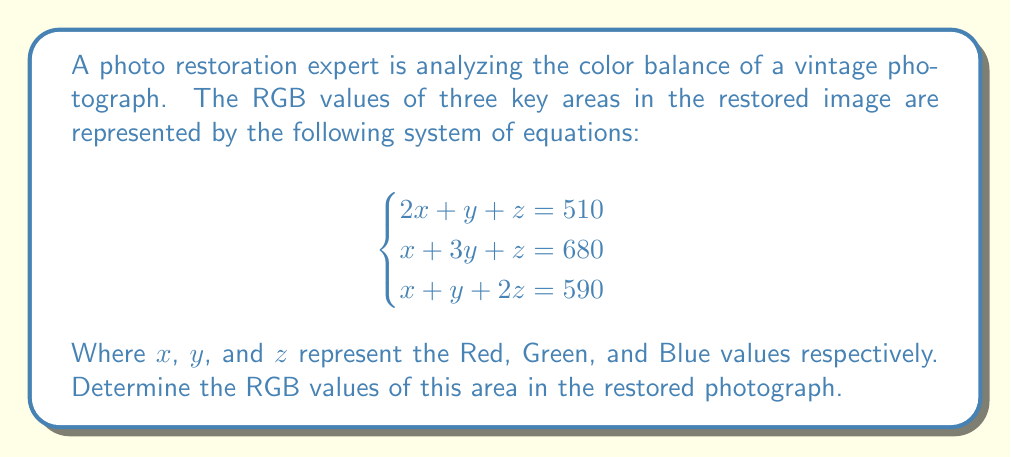Show me your answer to this math problem. To solve this system of equations, we'll use the elimination method:

1) Multiply the first equation by -1 and add it to the second equation:
   $$-2x - y - z = -510$$
   $$x + 3y + z = 680$$
   $$-x + 2y = 170$$ (Equation A)

2) Multiply the first equation by -1 and add it to the third equation:
   $$-2x - y - z = -510$$
   $$x + y + 2z = 590$$
   $$-x + z = 80$$ (Equation B)

3) Multiply Equation A by 2 and add it to Equation B:
   $$-2x + 4y = 340$$
   $$-x + z = 80$$
   $$-3x + 4y + z = 420$$ (Equation C)

4) Multiply the original first equation by 3 and subtract Equation C:
   $$6x + 3y + 3z = 1530$$
   $$-3x + 4y + z = 420$$
   $$9x - y + 2z = 1110$$

5) Multiply this by 1/9 to simplify:
   $$x - \frac{1}{9}y + \frac{2}{9}z = 123.33$$ (Equation D)

6) Subtract Equation B from Equation D:
   $$x - \frac{1}{9}y + \frac{2}{9}z = 123.33$$
   $$-x + z = 80$$
   $$-\frac{1}{9}y + \frac{11}{9}z = 203.33$$

7) Multiply by 9:
   $$-y + 11z = 1830$$ (Equation E)

8) Multiply Equation A by 5 and subtract Equation E:
   $$-5x + 10y = 850$$
   $$-y + 11z = 1830$$
   $$-5x + 11y - 11z = -980$$

9) Add this to 11 times the first original equation:
   $$-5x + 11y - 11z = -980$$
   $$22x + 11y + 11z = 5610$$
   $$17x = 4630$$

10) Solve for x:
    $$x = \frac{4630}{17} = 272.35 \approx 272$$

11) Substitute this value back into Equation A and B to solve for y and z:
    $$-272 + 2y = 170$$
    $$2y = 442$$
    $$y = 221$$

    $$-272 + z = 80$$
    $$z = 352$$

Therefore, the RGB values are (272, 221, 352).
Answer: (272, 221, 352) 